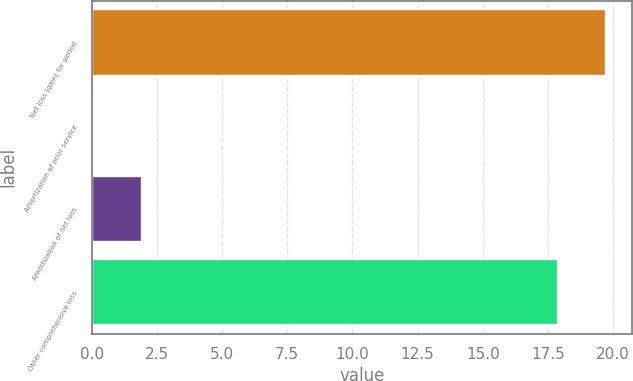Convert chart. <chart><loc_0><loc_0><loc_500><loc_500><bar_chart><fcel>Net loss (gain) for period<fcel>Amortization of prior service<fcel>Amortization of net loss<fcel>Other comprehensive loss<nl><fcel>19.73<fcel>0.1<fcel>1.93<fcel>17.9<nl></chart> 